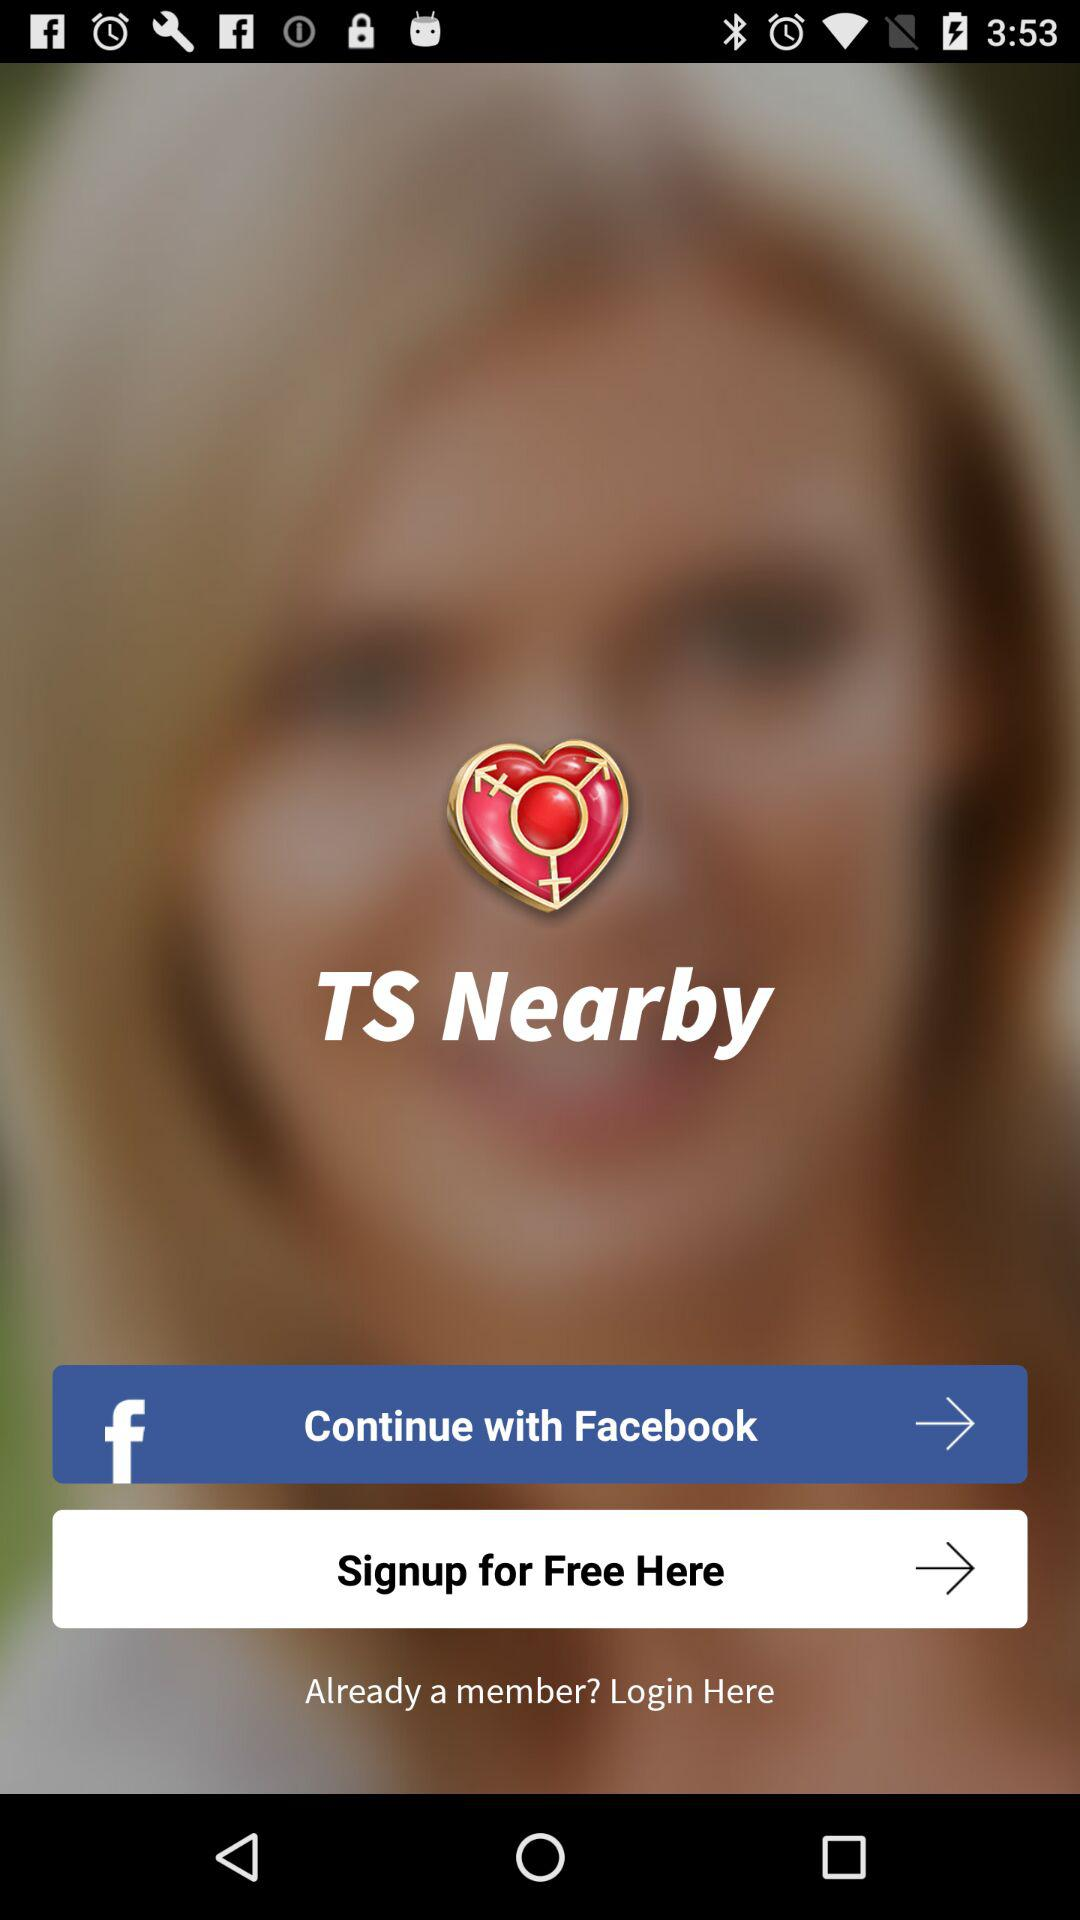Through what account can the user continue? The user can continue through "Facebook". 